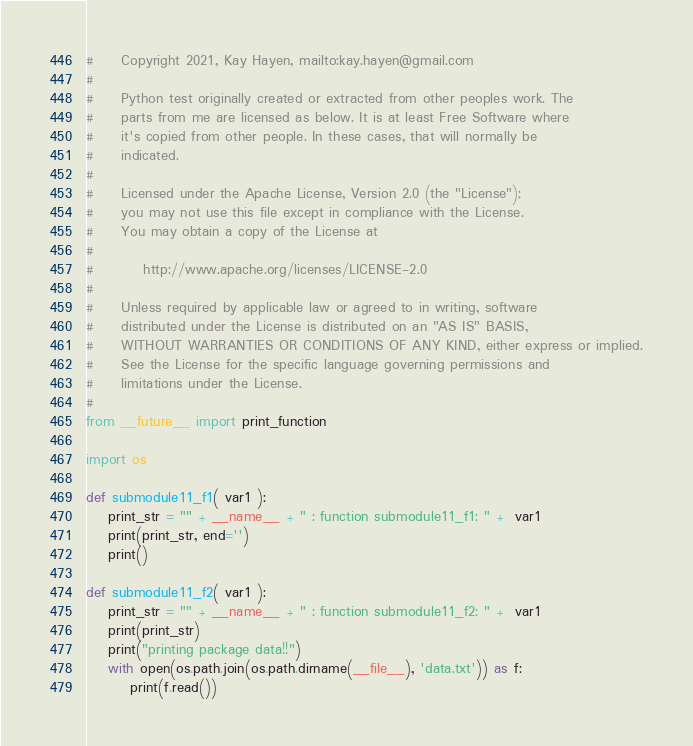Convert code to text. <code><loc_0><loc_0><loc_500><loc_500><_Python_>#     Copyright 2021, Kay Hayen, mailto:kay.hayen@gmail.com
#
#     Python test originally created or extracted from other peoples work. The
#     parts from me are licensed as below. It is at least Free Software where
#     it's copied from other people. In these cases, that will normally be
#     indicated.
#
#     Licensed under the Apache License, Version 2.0 (the "License");
#     you may not use this file except in compliance with the License.
#     You may obtain a copy of the License at
#
#         http://www.apache.org/licenses/LICENSE-2.0
#
#     Unless required by applicable law or agreed to in writing, software
#     distributed under the License is distributed on an "AS IS" BASIS,
#     WITHOUT WARRANTIES OR CONDITIONS OF ANY KIND, either express or implied.
#     See the License for the specific language governing permissions and
#     limitations under the License.
#
from __future__ import print_function

import os

def submodule11_f1( var1 ):
    print_str = "" + __name__ + " : function submodule11_f1: " +  var1
    print(print_str, end='')
    print()

def submodule11_f2( var1 ):
    print_str = "" + __name__ + " : function submodule11_f2: " +  var1
    print(print_str)
    print("printing package data!!")
    with open(os.path.join(os.path.dirname(__file__), 'data.txt')) as f:
        print(f.read())

</code> 